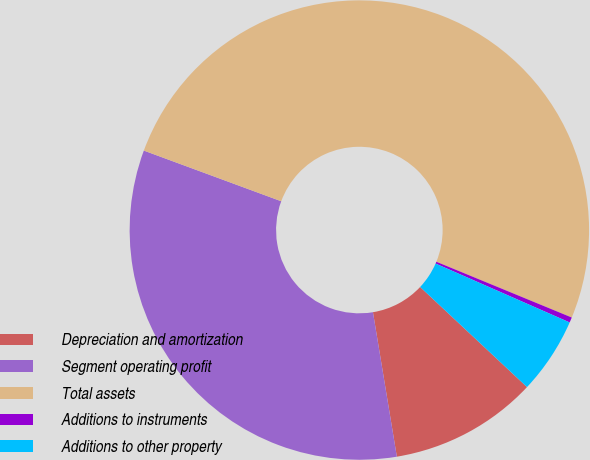Convert chart. <chart><loc_0><loc_0><loc_500><loc_500><pie_chart><fcel>Depreciation and amortization<fcel>Segment operating profit<fcel>Total assets<fcel>Additions to instruments<fcel>Additions to other property<nl><fcel>10.41%<fcel>33.23%<fcel>50.59%<fcel>0.37%<fcel>5.39%<nl></chart> 